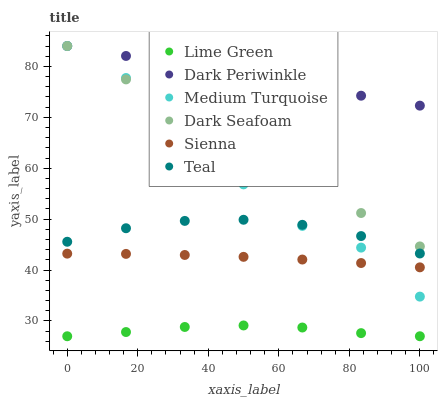Does Lime Green have the minimum area under the curve?
Answer yes or no. Yes. Does Dark Periwinkle have the maximum area under the curve?
Answer yes or no. Yes. Does Sienna have the minimum area under the curve?
Answer yes or no. No. Does Sienna have the maximum area under the curve?
Answer yes or no. No. Is Dark Periwinkle the smoothest?
Answer yes or no. Yes. Is Medium Turquoise the roughest?
Answer yes or no. Yes. Is Sienna the smoothest?
Answer yes or no. No. Is Sienna the roughest?
Answer yes or no. No. Does Lime Green have the lowest value?
Answer yes or no. Yes. Does Sienna have the lowest value?
Answer yes or no. No. Does Dark Periwinkle have the highest value?
Answer yes or no. Yes. Does Sienna have the highest value?
Answer yes or no. No. Is Sienna less than Dark Seafoam?
Answer yes or no. Yes. Is Teal greater than Lime Green?
Answer yes or no. Yes. Does Dark Periwinkle intersect Medium Turquoise?
Answer yes or no. Yes. Is Dark Periwinkle less than Medium Turquoise?
Answer yes or no. No. Is Dark Periwinkle greater than Medium Turquoise?
Answer yes or no. No. Does Sienna intersect Dark Seafoam?
Answer yes or no. No. 